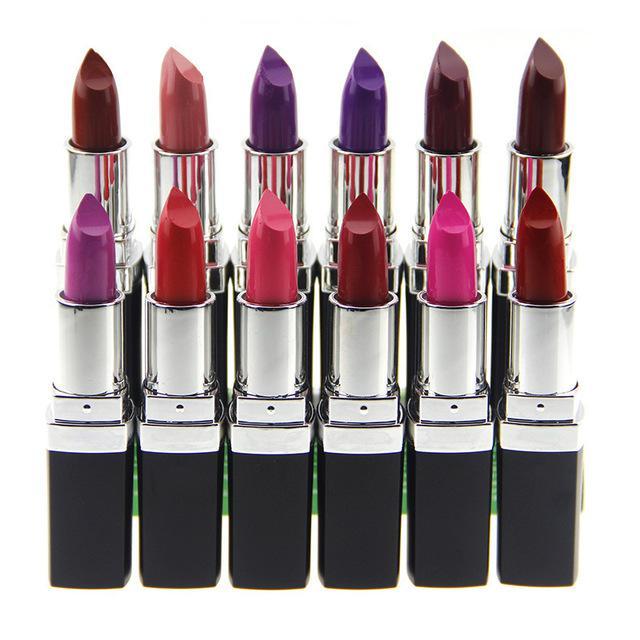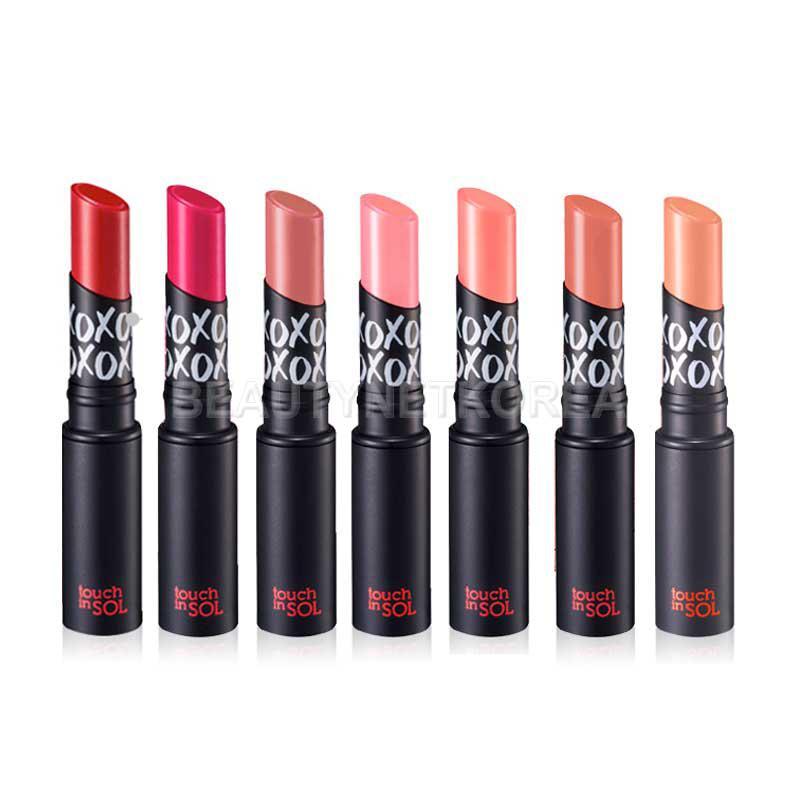The first image is the image on the left, the second image is the image on the right. Assess this claim about the two images: "The right image includes an odd number of lipsticks standing up with their caps off.". Correct or not? Answer yes or no. Yes. 